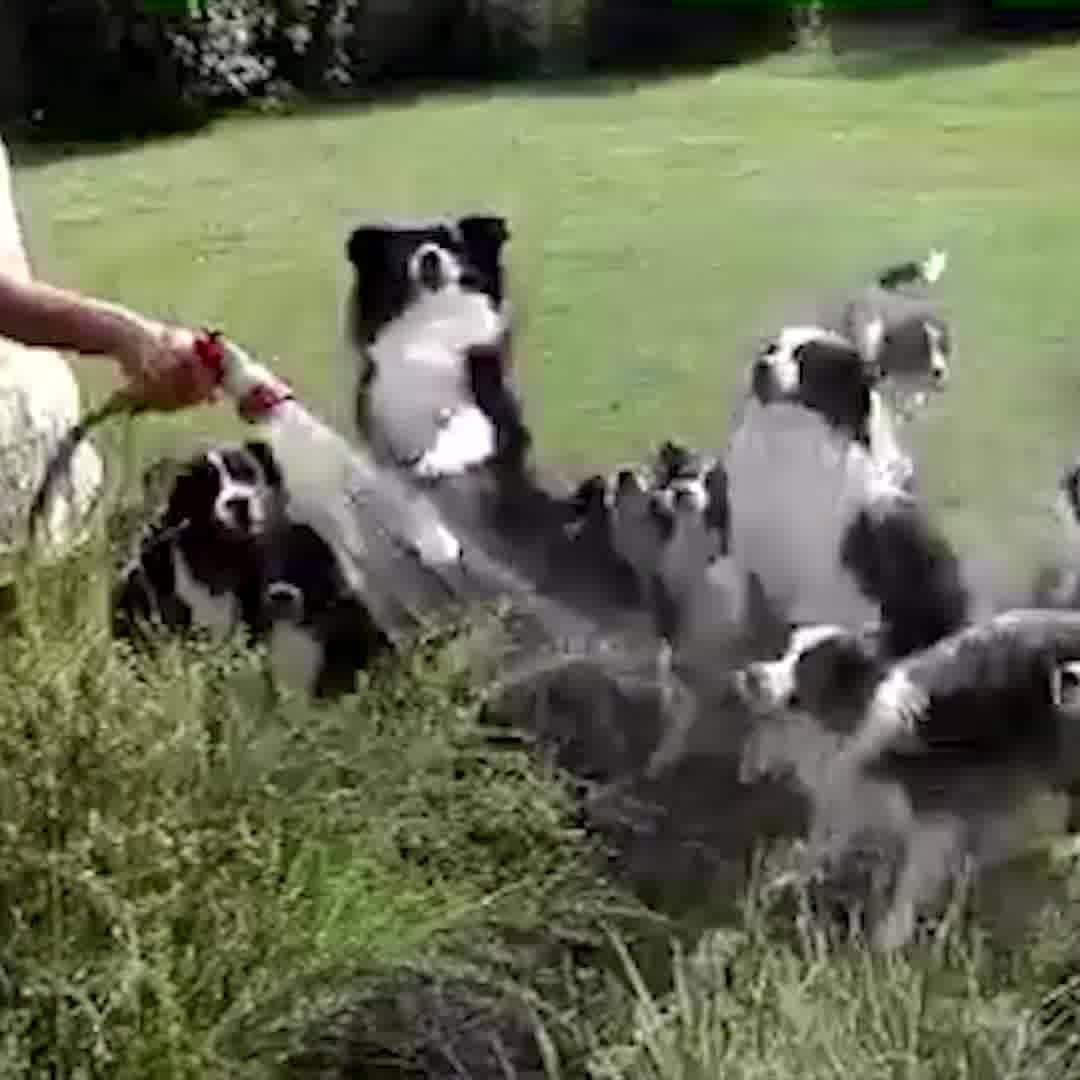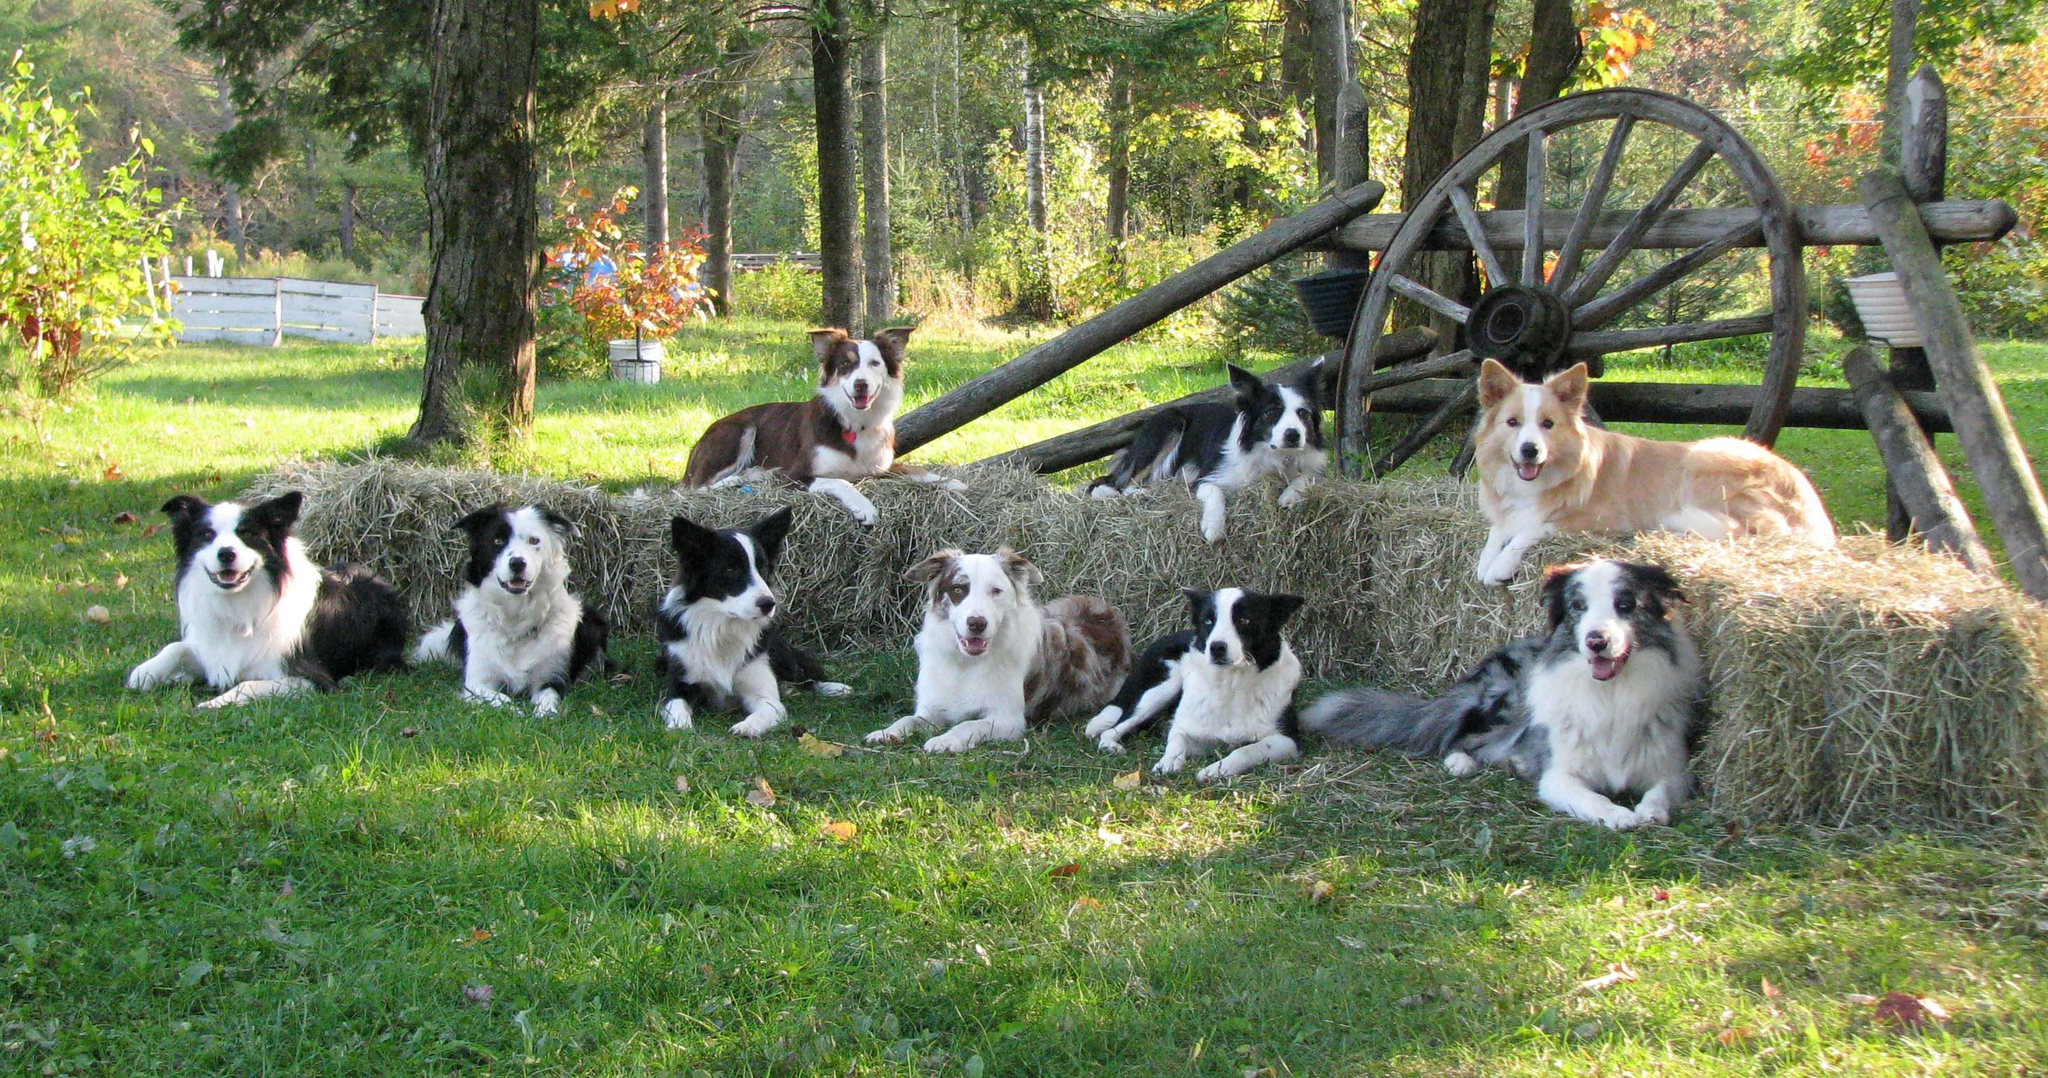The first image is the image on the left, the second image is the image on the right. Analyze the images presented: Is the assertion "There are at least half a dozen dogs lying in a line on the grass in one of the images." valid? Answer yes or no. Yes. The first image is the image on the left, the second image is the image on the right. Assess this claim about the two images: "An image shows a nozzle spraying water at a group of black-and-white dogs.". Correct or not? Answer yes or no. Yes. 